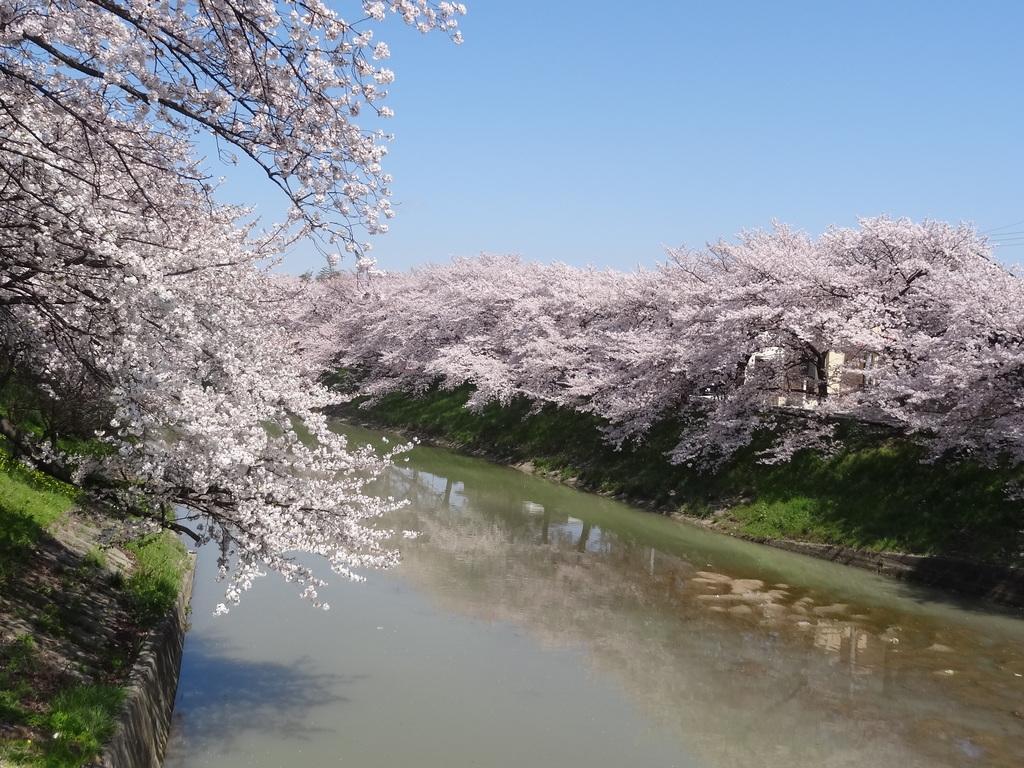Describe this image in one or two sentences. In this picture we can see many trees. On the trees we can see white flowers. In the bottom we can see the water. On the right there is a building. At the top we can see sky. In the bottom left we can see the grass. 